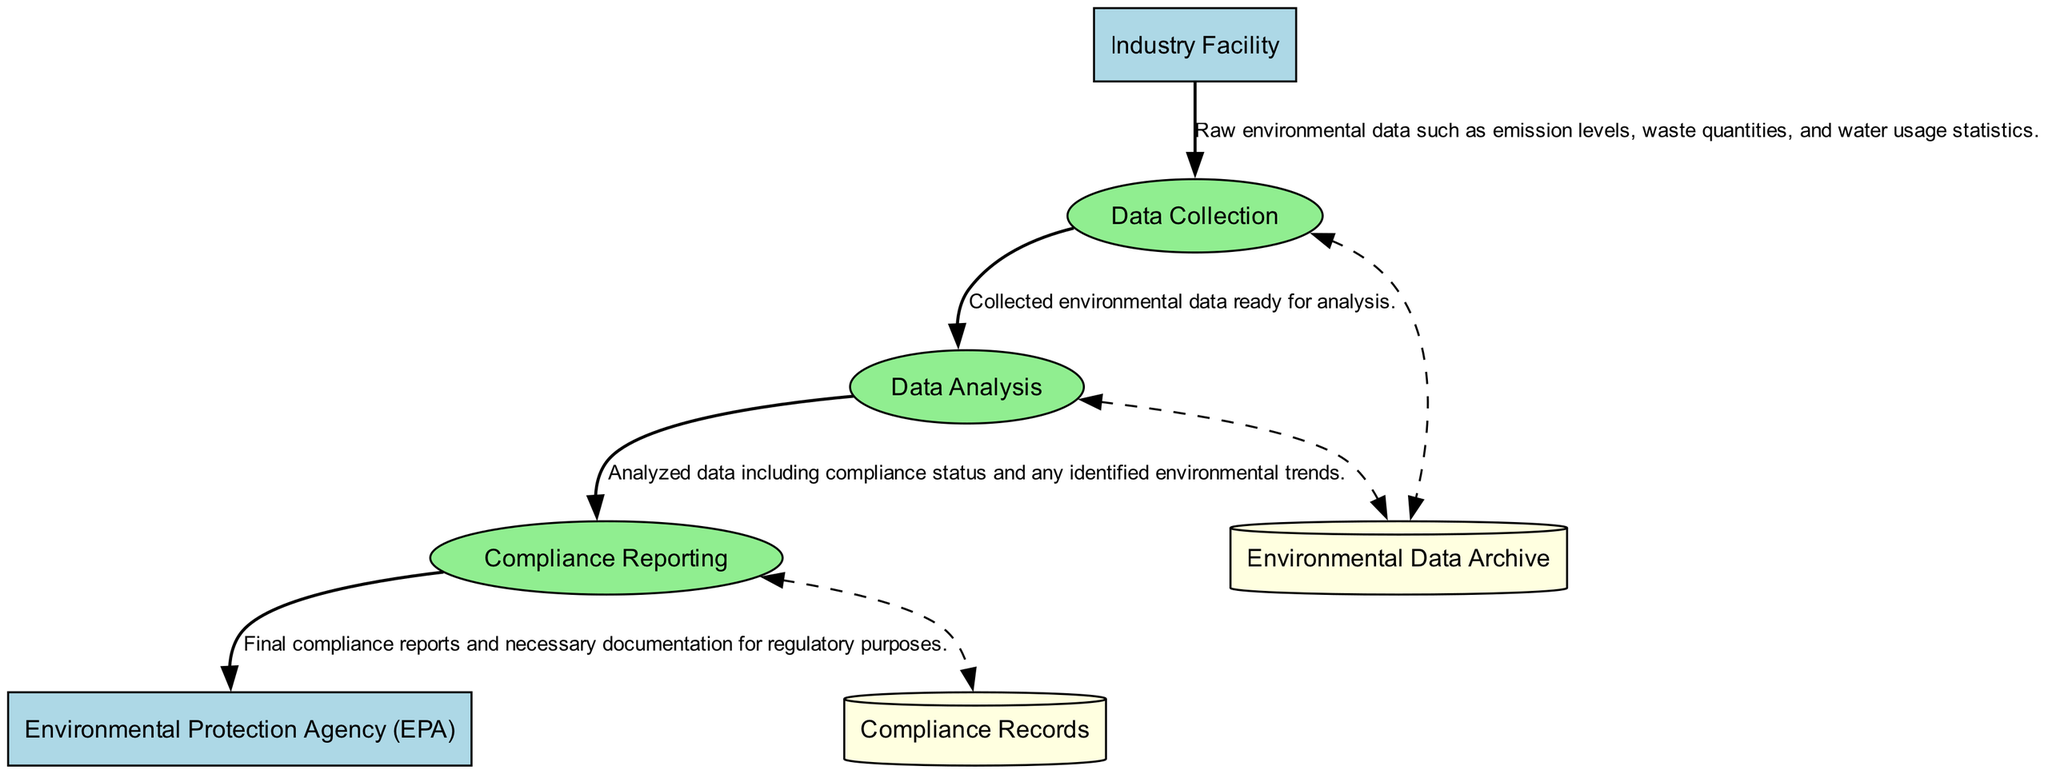What is the name of the external regulatory body? The diagram clearly identifies "Environmental Protection Agency (EPA)" as the regulatory body associated with compliance enforcement.
Answer: Environmental Protection Agency (EPA) How many processes are there in the diagram? By counting the listed processes, we find there are three: Data Collection, Data Analysis, and Compliance Reporting.
Answer: 3 What type of data is sent from the Industry Facility to Data Collection? The flow indicates that "Raw environmental data such as emission levels, waste quantities, and water usage statistics" is transferred to Data Collection.
Answer: Raw environmental data What is the final step that occurs in the data flow before reporting? The diagram shows that the last process before reporting is Data Analysis, where data is examined for compliance status and trends.
Answer: Data Analysis Where is the analyzed data stored after it is processed? According to the diagram, the analyzed data is stored in the "Environmental Data Archive," which acts as a repository for the collected and analyzed data.
Answer: Environmental Data Archive What do Compliance Reports include? Compliance Reporting takes analyzed data and creates reports that cover compliance status and identified trends, which are necessary for regulatory purposes.
Answer: Compliance status and identified trends Which two data stores are mentioned in the diagram? The diagram indicates two data stores: "Environmental Data Archive" and "Compliance Records," which handle data and compliance documentation, respectively.
Answer: Environmental Data Archive and Compliance Records Which process directly receives data from Data Collection? Based on the data flow, the process that receives information from Data Collection is Data Analysis.
Answer: Data Analysis What type of relationship is indicated between Compliance Reporting and Compliance Records? The diagram shows a bi-directional dashed line, indicating a connection that allows the flow of compliance reports and potentially the retrieval of records as needed.
Answer: Bi-directional connection 